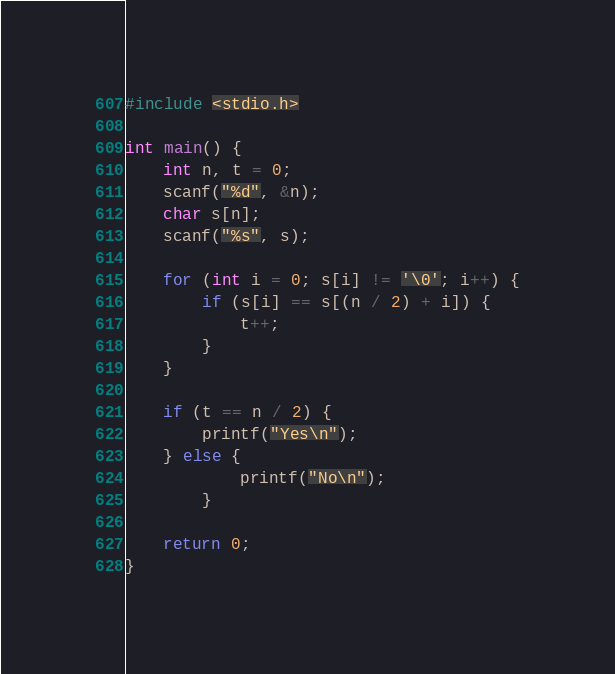Convert code to text. <code><loc_0><loc_0><loc_500><loc_500><_C++_>#include <stdio.h>

int main() {
    int n, t = 0;
    scanf("%d", &n);
    char s[n];
    scanf("%s", s);
    
    for (int i = 0; s[i] != '\0'; i++) {
        if (s[i] == s[(n / 2) + i]) {
            t++;
        }
    }

    if (t == n / 2) {
        printf("Yes\n");
    } else {
            printf("No\n");
        }

    return 0;
}</code> 